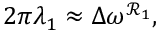<formula> <loc_0><loc_0><loc_500><loc_500>2 \pi \lambda _ { 1 } \approx \Delta \omega ^ { \mathcal { R } _ { 1 } } ,</formula> 